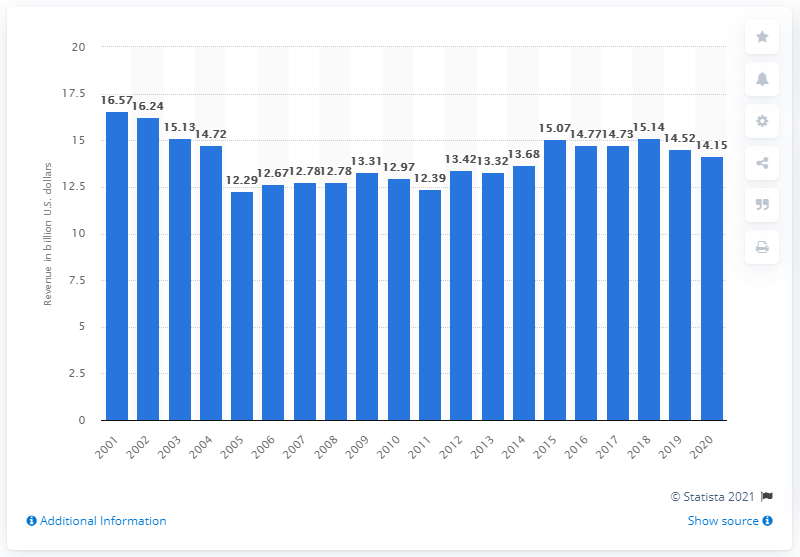Indicate a few pertinent items in this graphic. In 2020, Electrolux generated approximately 14.15 million dollars in revenue in the United States. Electrolux's overall revenue range is between 14.15 billion and.. 